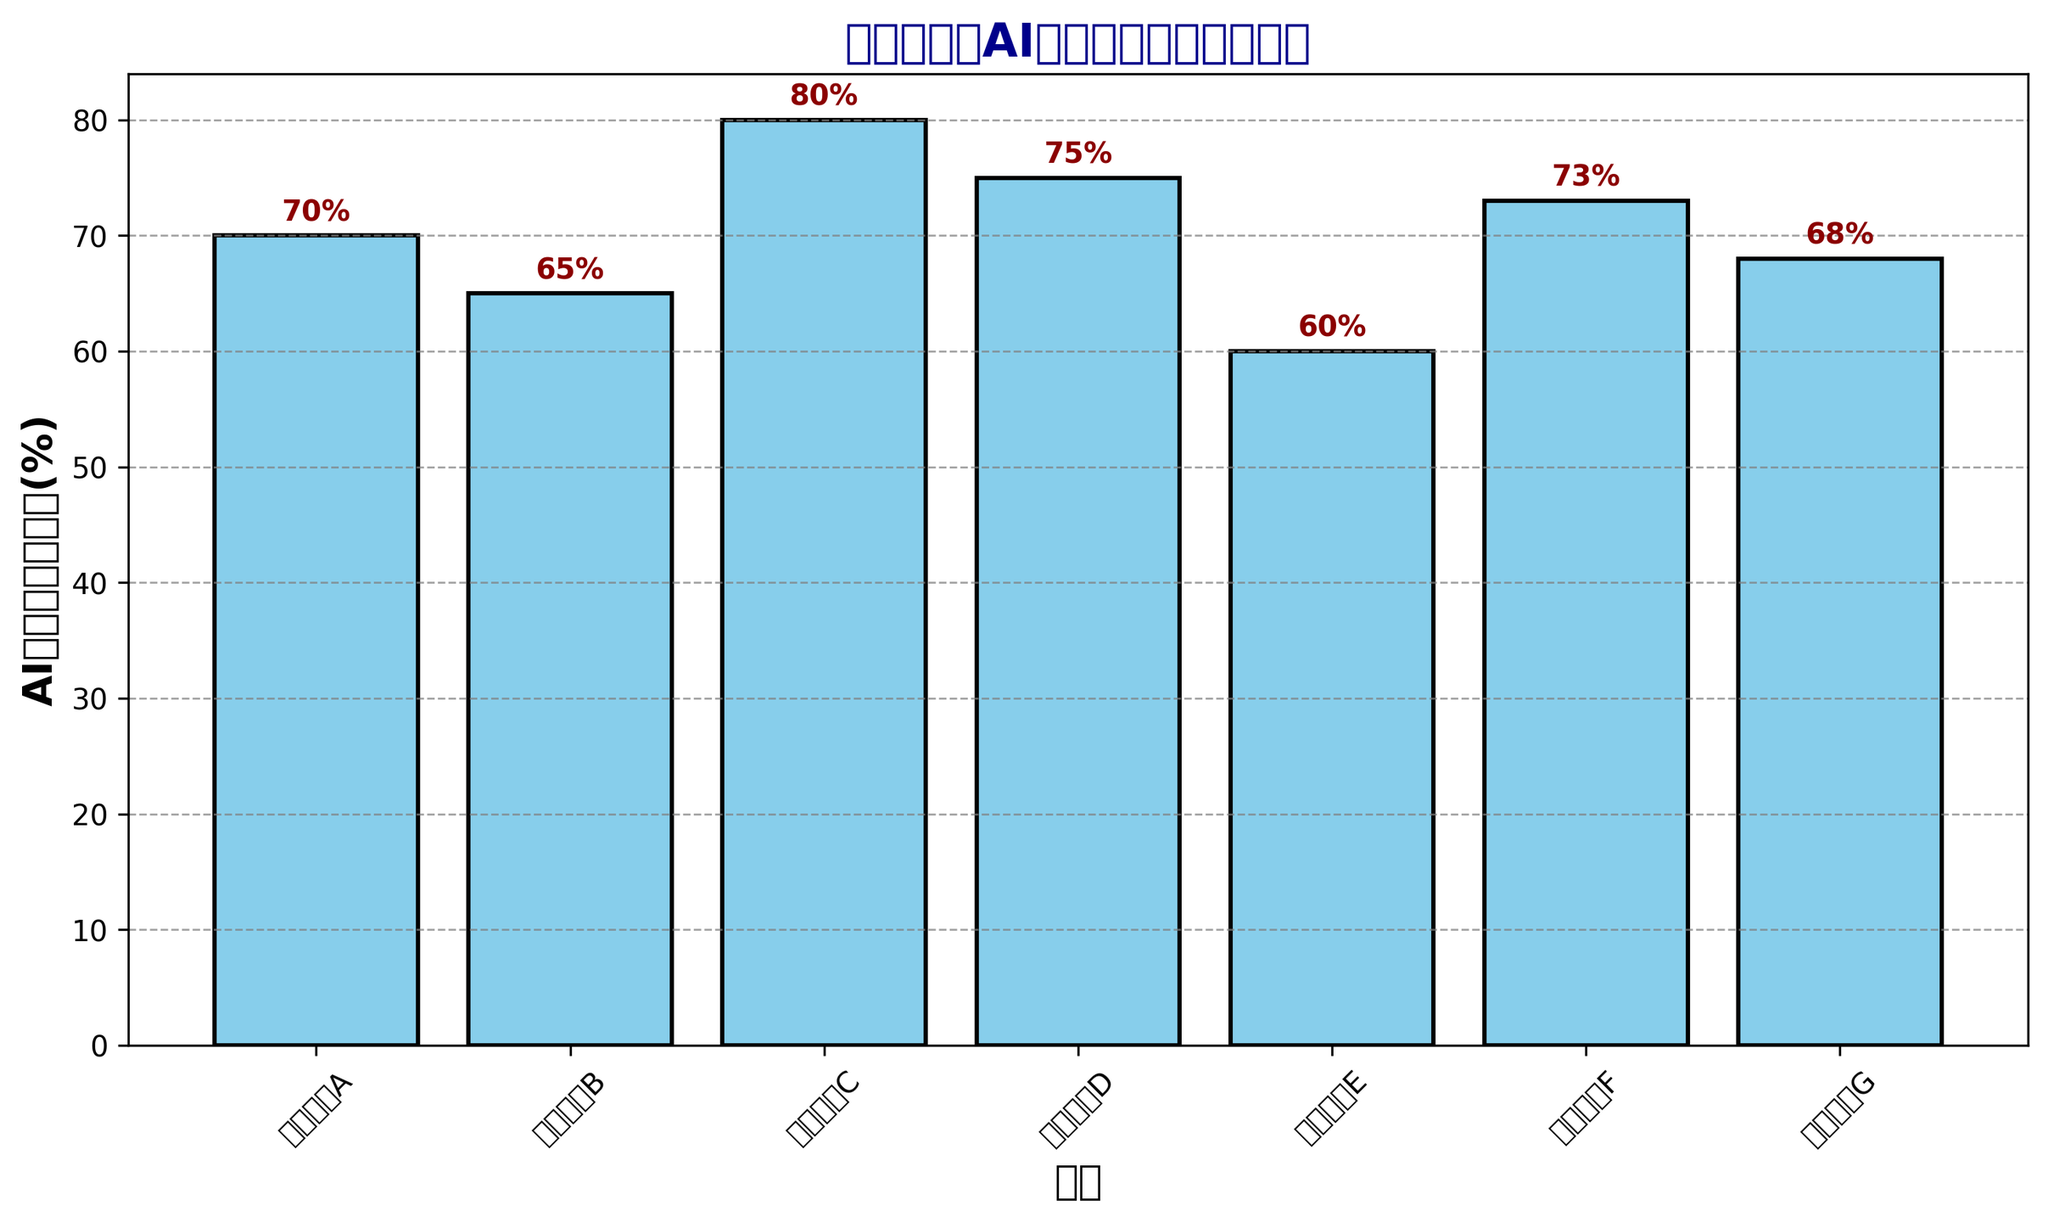What's the AI推荐系统使用率(%) for 购物网站A? The AI推荐系统使用率(%) can be read directly from the bar corresponding to 购物网站A. The height of the bar indicates the value.
Answer: 70% Which website has the highest AI推荐系统使用率(%)? Among all the bars in the figure, the one that extends the highest reaches 80%, which corresponds to 购物网站C.
Answer: 购物网站C By how much does the AI推荐系统使用率(%) of 购物网站D exceed that of 购物网站E? The AI推荐系统使用率(%) for 购物网站D is 75%, and for 购物网站E is 60%. The difference can be found by subtracting 60 from 75.
Answer: 15% Which websites have an AI推荐系统使用率(%) greater than 70%? Examine the heights of the bars and identify those with percentages above 70. These include 购物网站A (70%), 购物网站C (80%), 购物网站D (75%), and 购物网站F (73%).
Answer: 购物网站A, 购物网站C, 购物网站D, 购物网站F Calculate the average AI推荐系统使用率(%) for all websites. Sum up all AI推荐系统使用率(%) values (70 + 65 + 80 + 75 + 60 + 73 + 68) and then divide by the number of websites (7). The total is 491, so the average is 491/7.
Answer: 70.14% What is the color of the bars representing AI推荐系统使用率(%)? Visual inspection of the bars shows they are colored uniformly. The description details the color as skyblue.
Answer: Skyblue Which website uses its AI recommendation system the least? The shortest bar corresponds to the smallest usage rate, which in this chart is 60%, belonging to 购物网站E.
Answer: 购物网站E Is the AI推荐系统使用率(%) for 购物网站B higher or lower than the average usage rate? The AI推荐系统使用率(%) for 购物网站B is 65%. The average AI使用率 is calculated to be 70.14%. Since 65% is less than 70.14%, it is lower.
Answer: Lower 